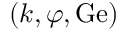Convert formula to latex. <formula><loc_0><loc_0><loc_500><loc_500>( k , \varphi , G e )</formula> 